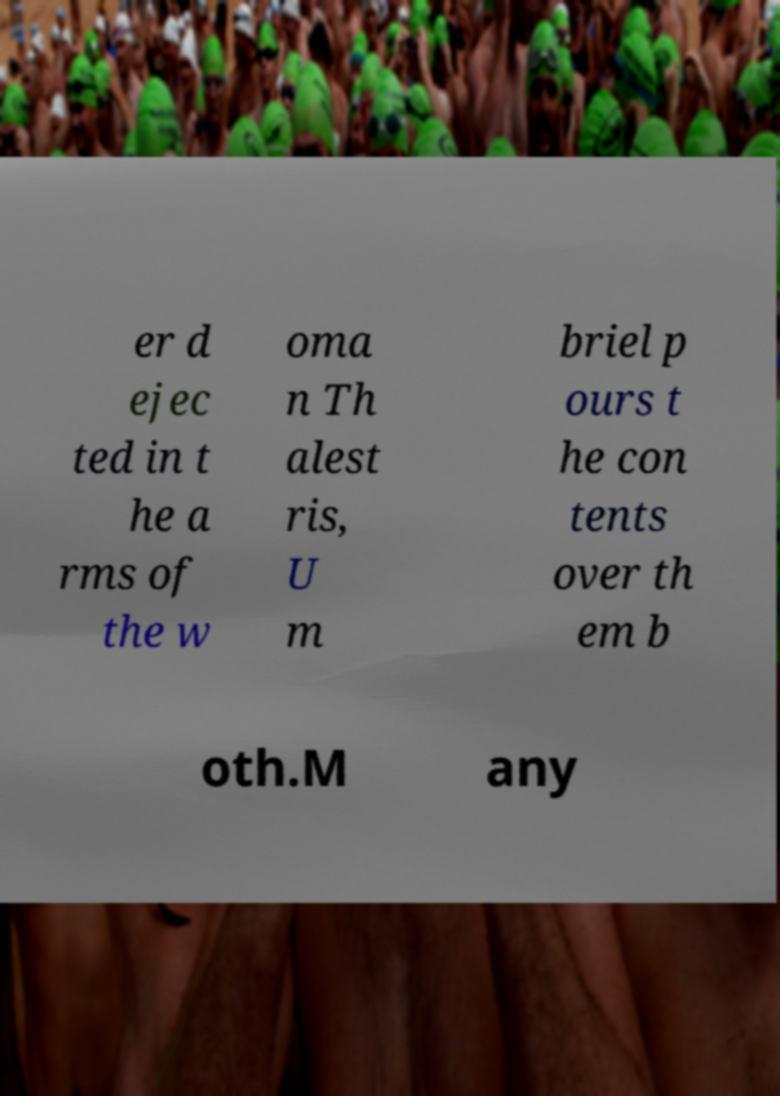I need the written content from this picture converted into text. Can you do that? er d ejec ted in t he a rms of the w oma n Th alest ris, U m briel p ours t he con tents over th em b oth.M any 